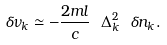<formula> <loc_0><loc_0><loc_500><loc_500>\delta \nu _ { k } \simeq - \frac { 2 m l } c \ \Delta _ { k } ^ { 2 } \ \delta n _ { k } .</formula> 